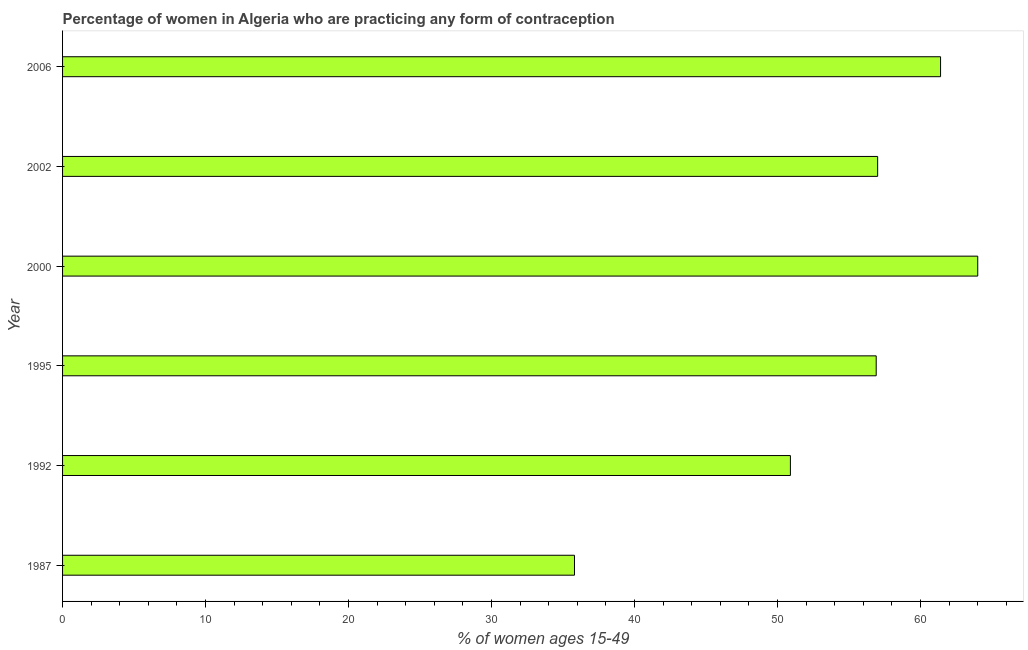What is the title of the graph?
Your answer should be very brief. Percentage of women in Algeria who are practicing any form of contraception. What is the label or title of the X-axis?
Provide a short and direct response. % of women ages 15-49. What is the label or title of the Y-axis?
Offer a terse response. Year. What is the contraceptive prevalence in 1987?
Your answer should be compact. 35.8. Across all years, what is the minimum contraceptive prevalence?
Provide a succinct answer. 35.8. In which year was the contraceptive prevalence maximum?
Give a very brief answer. 2000. In which year was the contraceptive prevalence minimum?
Your answer should be very brief. 1987. What is the sum of the contraceptive prevalence?
Keep it short and to the point. 326. What is the average contraceptive prevalence per year?
Offer a very short reply. 54.33. What is the median contraceptive prevalence?
Make the answer very short. 56.95. What is the ratio of the contraceptive prevalence in 1992 to that in 1995?
Your answer should be compact. 0.9. Is the contraceptive prevalence in 1987 less than that in 1995?
Offer a terse response. Yes. Is the difference between the contraceptive prevalence in 1995 and 2000 greater than the difference between any two years?
Offer a terse response. No. Is the sum of the contraceptive prevalence in 1995 and 2000 greater than the maximum contraceptive prevalence across all years?
Offer a very short reply. Yes. What is the difference between the highest and the lowest contraceptive prevalence?
Your answer should be very brief. 28.2. In how many years, is the contraceptive prevalence greater than the average contraceptive prevalence taken over all years?
Provide a short and direct response. 4. How many years are there in the graph?
Offer a very short reply. 6. What is the % of women ages 15-49 of 1987?
Make the answer very short. 35.8. What is the % of women ages 15-49 in 1992?
Your answer should be very brief. 50.9. What is the % of women ages 15-49 of 1995?
Make the answer very short. 56.9. What is the % of women ages 15-49 in 2000?
Make the answer very short. 64. What is the % of women ages 15-49 in 2006?
Ensure brevity in your answer.  61.4. What is the difference between the % of women ages 15-49 in 1987 and 1992?
Your response must be concise. -15.1. What is the difference between the % of women ages 15-49 in 1987 and 1995?
Make the answer very short. -21.1. What is the difference between the % of women ages 15-49 in 1987 and 2000?
Your answer should be very brief. -28.2. What is the difference between the % of women ages 15-49 in 1987 and 2002?
Keep it short and to the point. -21.2. What is the difference between the % of women ages 15-49 in 1987 and 2006?
Your answer should be very brief. -25.6. What is the difference between the % of women ages 15-49 in 1992 and 1995?
Make the answer very short. -6. What is the difference between the % of women ages 15-49 in 1992 and 2000?
Your answer should be very brief. -13.1. What is the difference between the % of women ages 15-49 in 1992 and 2006?
Your answer should be compact. -10.5. What is the difference between the % of women ages 15-49 in 1995 and 2000?
Offer a very short reply. -7.1. What is the difference between the % of women ages 15-49 in 1995 and 2002?
Give a very brief answer. -0.1. What is the difference between the % of women ages 15-49 in 2000 and 2002?
Ensure brevity in your answer.  7. What is the ratio of the % of women ages 15-49 in 1987 to that in 1992?
Your response must be concise. 0.7. What is the ratio of the % of women ages 15-49 in 1987 to that in 1995?
Give a very brief answer. 0.63. What is the ratio of the % of women ages 15-49 in 1987 to that in 2000?
Provide a short and direct response. 0.56. What is the ratio of the % of women ages 15-49 in 1987 to that in 2002?
Your response must be concise. 0.63. What is the ratio of the % of women ages 15-49 in 1987 to that in 2006?
Ensure brevity in your answer.  0.58. What is the ratio of the % of women ages 15-49 in 1992 to that in 1995?
Your answer should be compact. 0.9. What is the ratio of the % of women ages 15-49 in 1992 to that in 2000?
Make the answer very short. 0.8. What is the ratio of the % of women ages 15-49 in 1992 to that in 2002?
Give a very brief answer. 0.89. What is the ratio of the % of women ages 15-49 in 1992 to that in 2006?
Provide a succinct answer. 0.83. What is the ratio of the % of women ages 15-49 in 1995 to that in 2000?
Make the answer very short. 0.89. What is the ratio of the % of women ages 15-49 in 1995 to that in 2006?
Ensure brevity in your answer.  0.93. What is the ratio of the % of women ages 15-49 in 2000 to that in 2002?
Offer a terse response. 1.12. What is the ratio of the % of women ages 15-49 in 2000 to that in 2006?
Provide a succinct answer. 1.04. What is the ratio of the % of women ages 15-49 in 2002 to that in 2006?
Your answer should be compact. 0.93. 